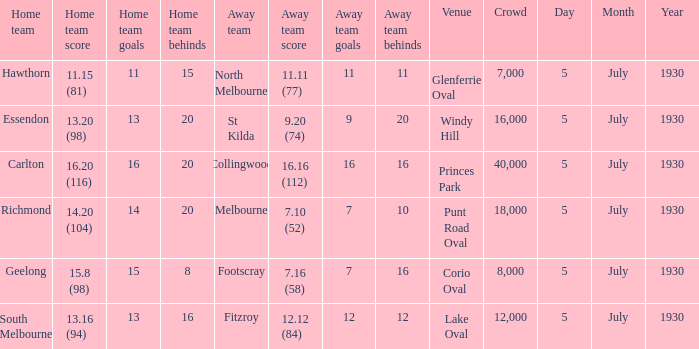What is the venue when fitzroy was the away team? Lake Oval. 